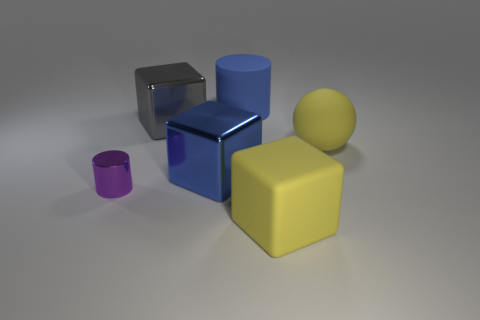Add 3 yellow matte blocks. How many objects exist? 9 Subtract all spheres. How many objects are left? 5 Subtract 0 cyan cylinders. How many objects are left? 6 Subtract all blue shiny blocks. Subtract all large gray cubes. How many objects are left? 4 Add 6 small things. How many small things are left? 7 Add 2 big matte spheres. How many big matte spheres exist? 3 